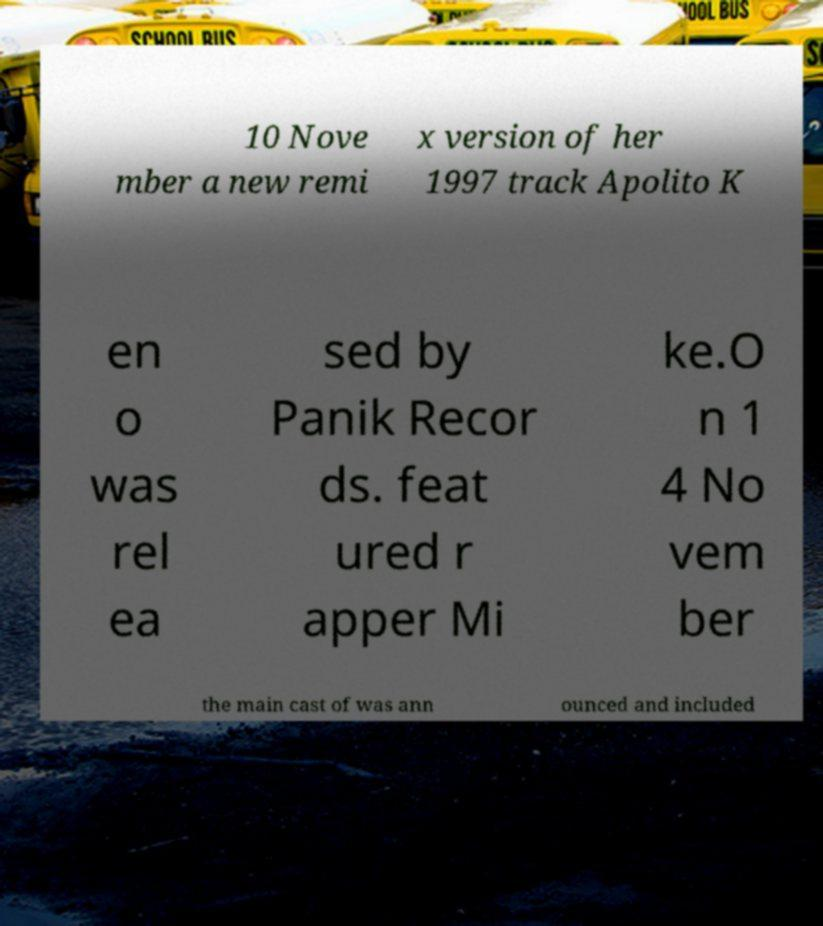Could you assist in decoding the text presented in this image and type it out clearly? 10 Nove mber a new remi x version of her 1997 track Apolito K en o was rel ea sed by Panik Recor ds. feat ured r apper Mi ke.O n 1 4 No vem ber the main cast of was ann ounced and included 